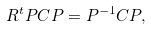<formula> <loc_0><loc_0><loc_500><loc_500>R ^ { t } P C P = P ^ { - 1 } C P ,</formula> 